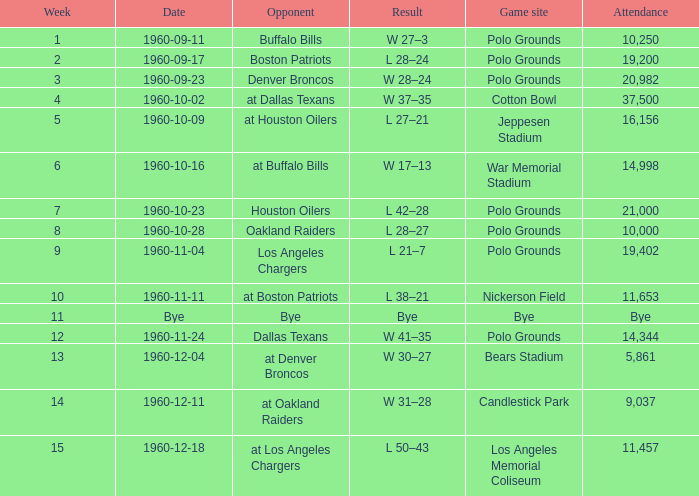What was the date of their performance at candlestick park? 1960-12-11. 